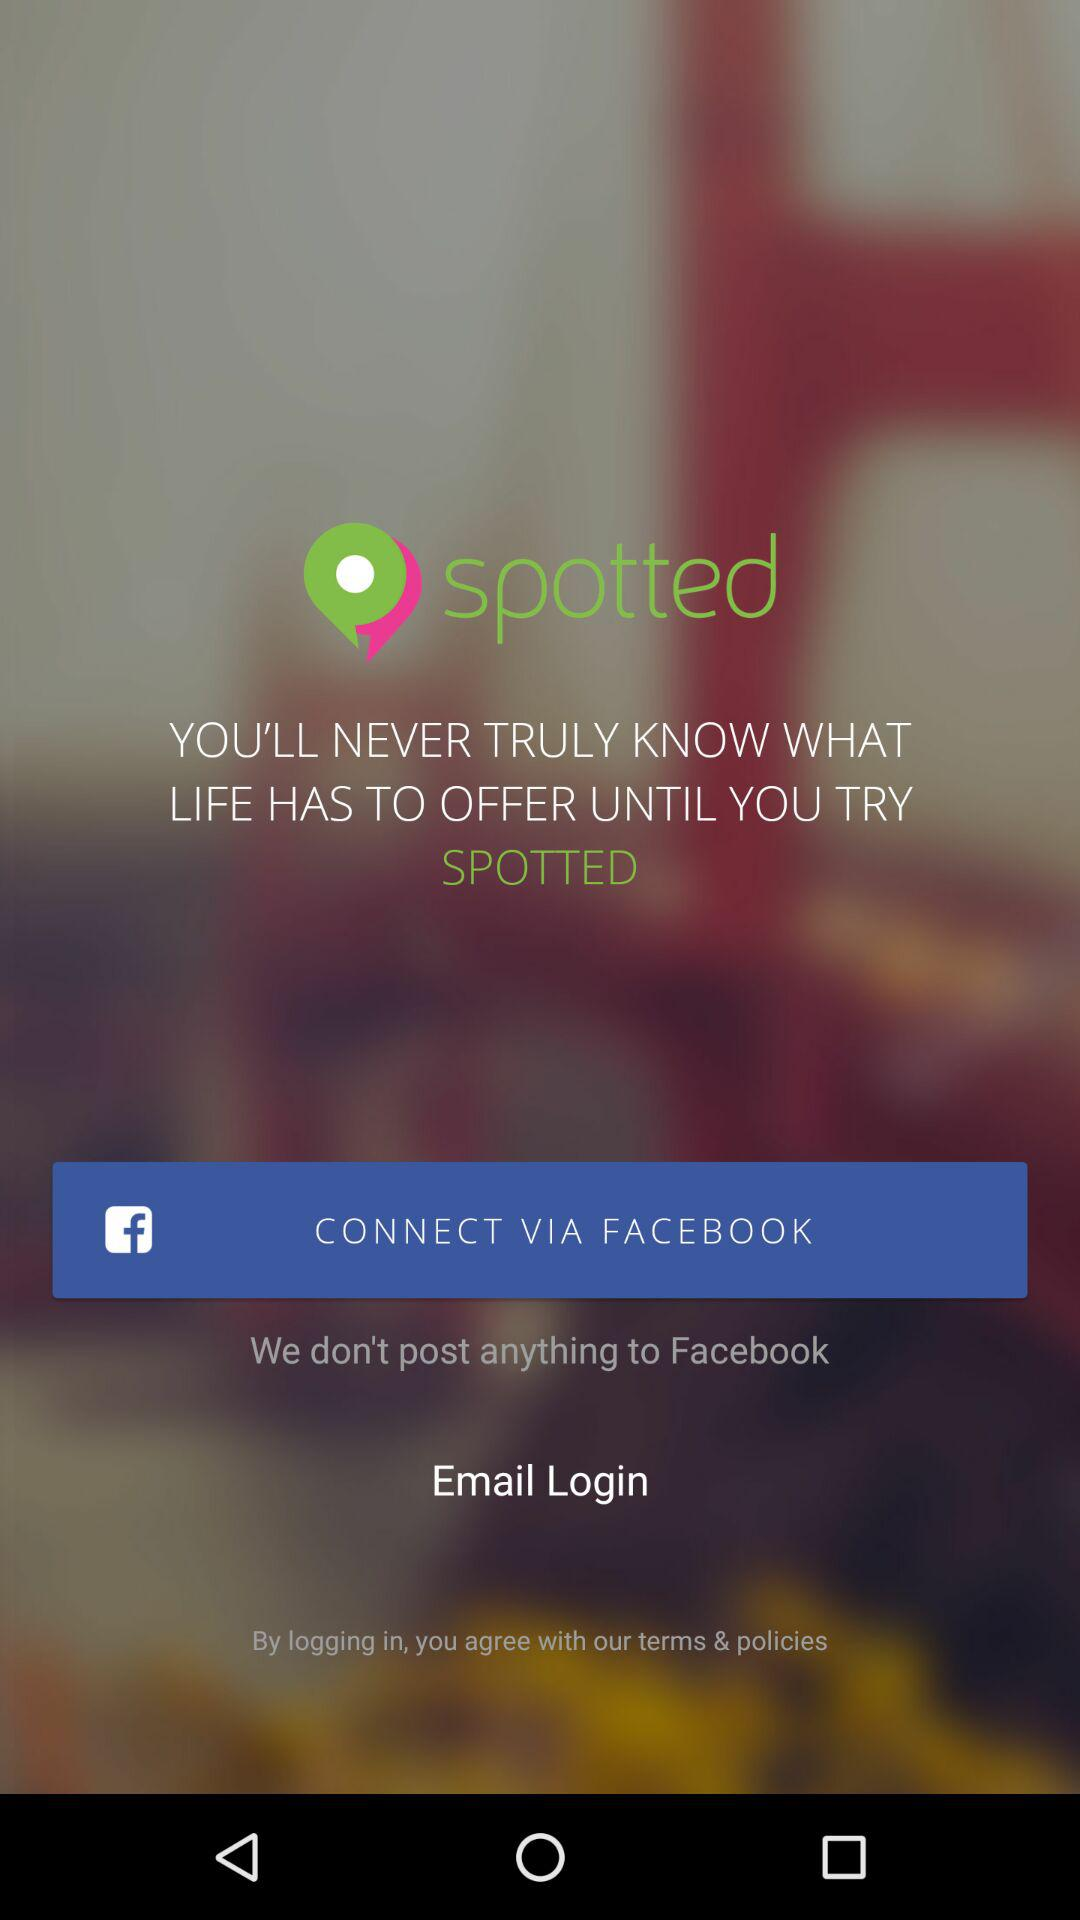What is the app name? The app name is "Spotted". 